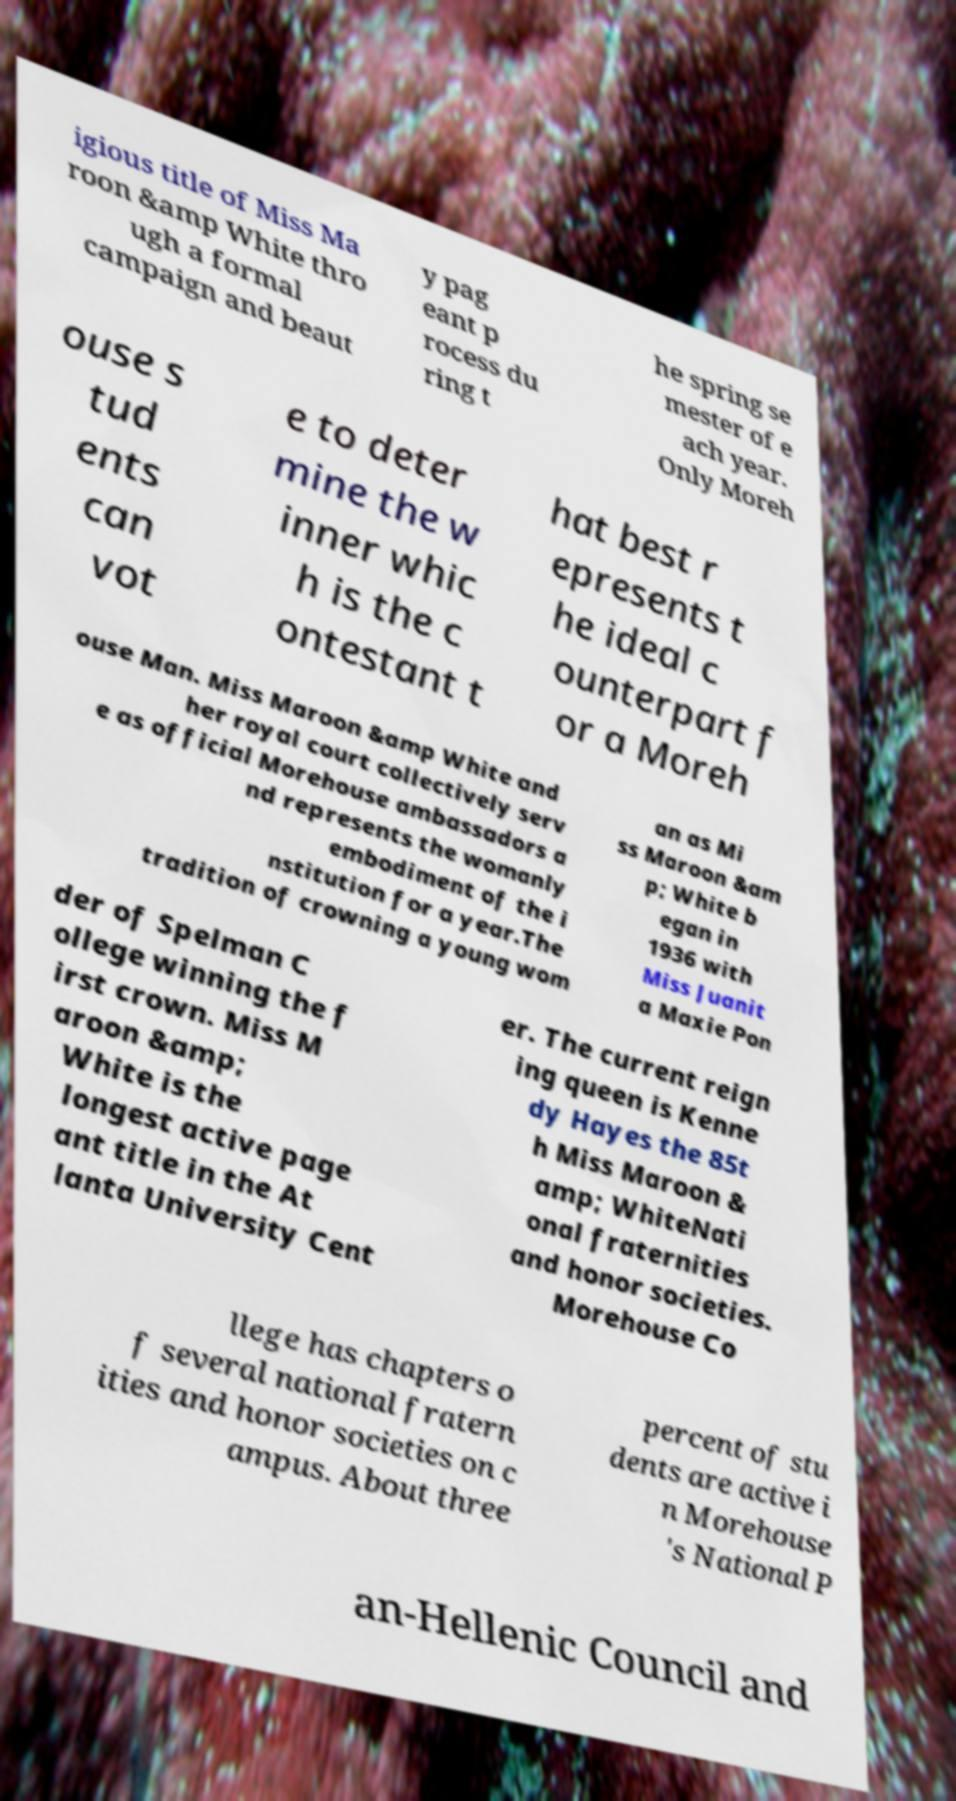Can you accurately transcribe the text from the provided image for me? igious title of Miss Ma roon &amp White thro ugh a formal campaign and beaut y pag eant p rocess du ring t he spring se mester of e ach year. Only Moreh ouse s tud ents can vot e to deter mine the w inner whic h is the c ontestant t hat best r epresents t he ideal c ounterpart f or a Moreh ouse Man. Miss Maroon &amp White and her royal court collectively serv e as official Morehouse ambassadors a nd represents the womanly embodiment of the i nstitution for a year.The tradition of crowning a young wom an as Mi ss Maroon &am p; White b egan in 1936 with Miss Juanit a Maxie Pon der of Spelman C ollege winning the f irst crown. Miss M aroon &amp; White is the longest active page ant title in the At lanta University Cent er. The current reign ing queen is Kenne dy Hayes the 85t h Miss Maroon & amp; WhiteNati onal fraternities and honor societies. Morehouse Co llege has chapters o f several national fratern ities and honor societies on c ampus. About three percent of stu dents are active i n Morehouse 's National P an-Hellenic Council and 